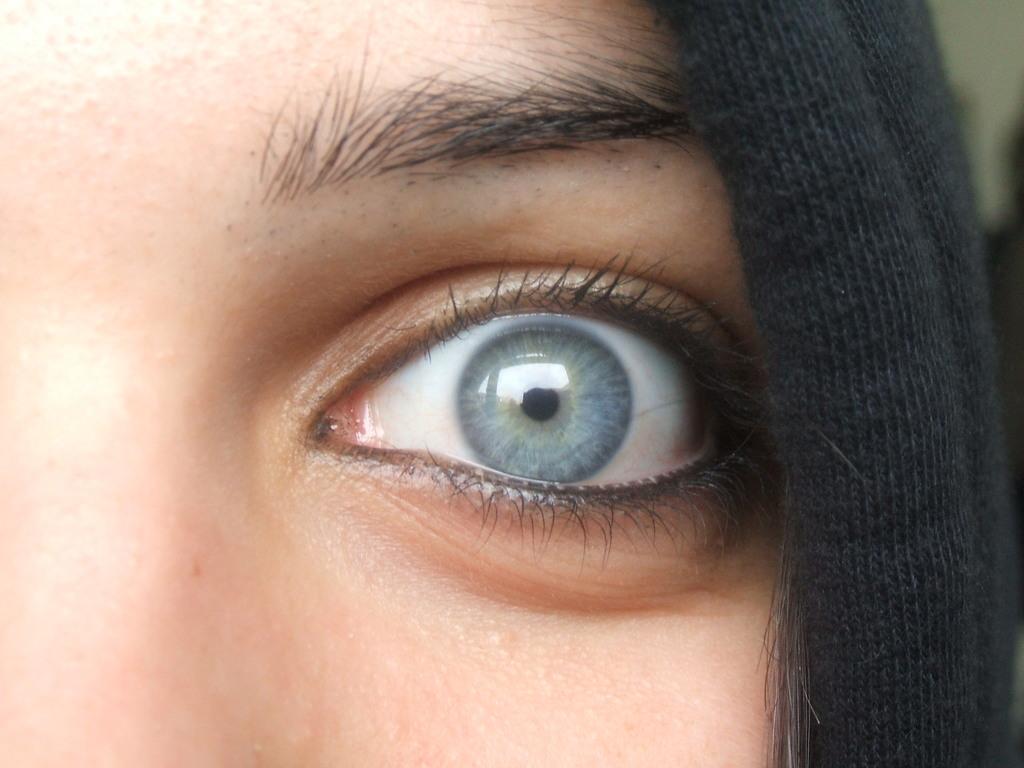Describe this image in one or two sentences. In this image there an eye of the person. On the right side there is an object which is black in colour and there is an eyebrow. 